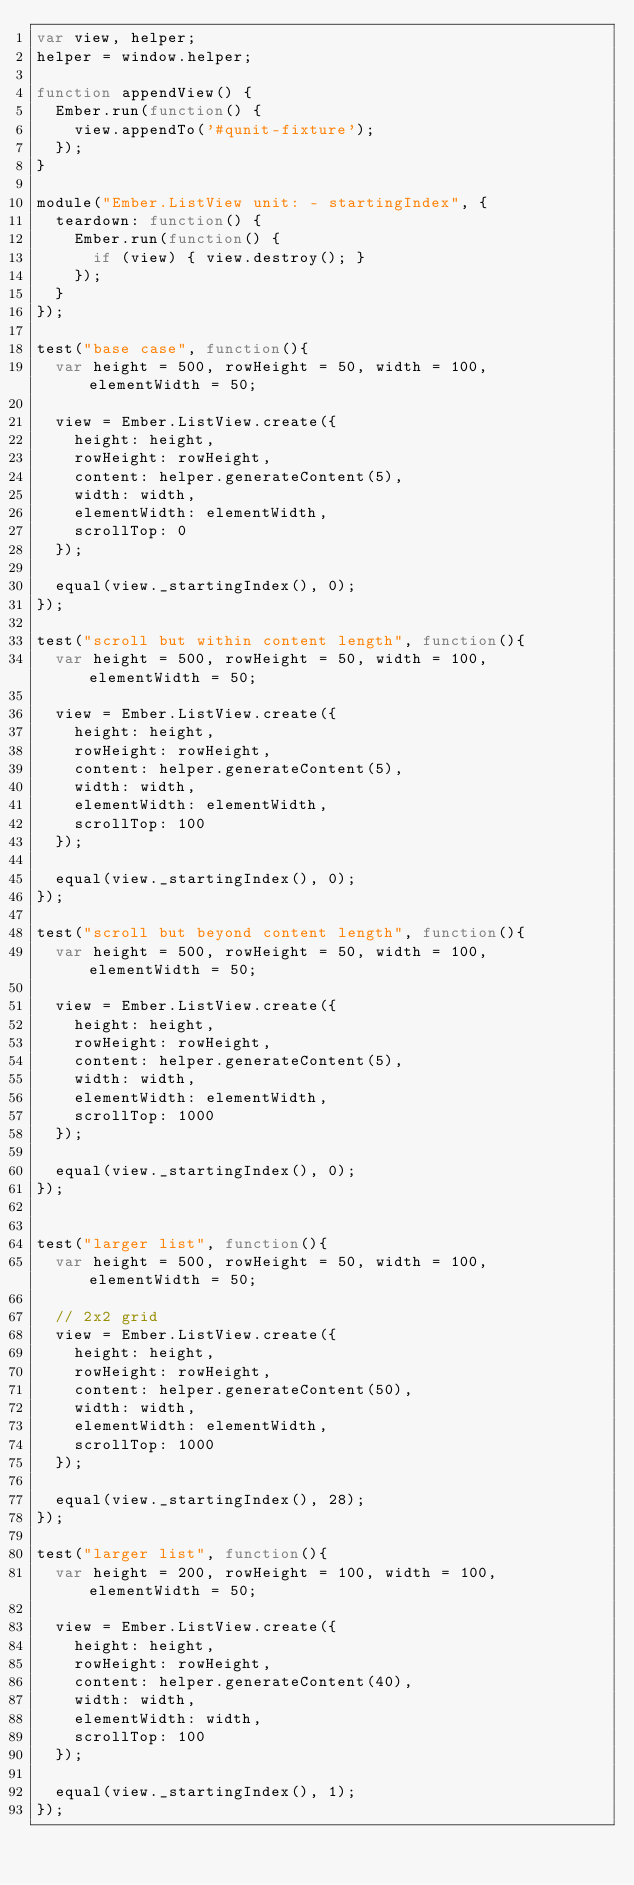<code> <loc_0><loc_0><loc_500><loc_500><_JavaScript_>var view, helper;
helper = window.helper;

function appendView() {
  Ember.run(function() {
    view.appendTo('#qunit-fixture');
  });
}

module("Ember.ListView unit: - startingIndex", {
  teardown: function() {
    Ember.run(function() {
      if (view) { view.destroy(); }
    });
  }
});

test("base case", function(){
  var height = 500, rowHeight = 50, width = 100, elementWidth = 50;

  view = Ember.ListView.create({
    height: height,
    rowHeight: rowHeight,
    content: helper.generateContent(5),
    width: width,
    elementWidth: elementWidth,
    scrollTop: 0
  });

  equal(view._startingIndex(), 0);
});

test("scroll but within content length", function(){
  var height = 500, rowHeight = 50, width = 100, elementWidth = 50;

  view = Ember.ListView.create({
    height: height,
    rowHeight: rowHeight,
    content: helper.generateContent(5),
    width: width,
    elementWidth: elementWidth,
    scrollTop: 100
  });

  equal(view._startingIndex(), 0);
});

test("scroll but beyond content length", function(){
  var height = 500, rowHeight = 50, width = 100, elementWidth = 50;

  view = Ember.ListView.create({
    height: height,
    rowHeight: rowHeight,
    content: helper.generateContent(5),
    width: width,
    elementWidth: elementWidth,
    scrollTop: 1000
  });

  equal(view._startingIndex(), 0);
});


test("larger list", function(){
  var height = 500, rowHeight = 50, width = 100, elementWidth = 50;

  // 2x2 grid
  view = Ember.ListView.create({
    height: height,
    rowHeight: rowHeight,
    content: helper.generateContent(50),
    width: width,
    elementWidth: elementWidth,
    scrollTop: 1000
  });

  equal(view._startingIndex(), 28);
});

test("larger list", function(){
  var height = 200, rowHeight = 100, width = 100, elementWidth = 50;

  view = Ember.ListView.create({
    height: height,
    rowHeight: rowHeight,
    content: helper.generateContent(40),
    width: width,
    elementWidth: width,
    scrollTop: 100
  });

  equal(view._startingIndex(), 1);
});

</code> 